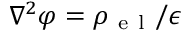<formula> <loc_0><loc_0><loc_500><loc_500>\nabla ^ { 2 } \varphi = \rho _ { e l } / \epsilon</formula> 